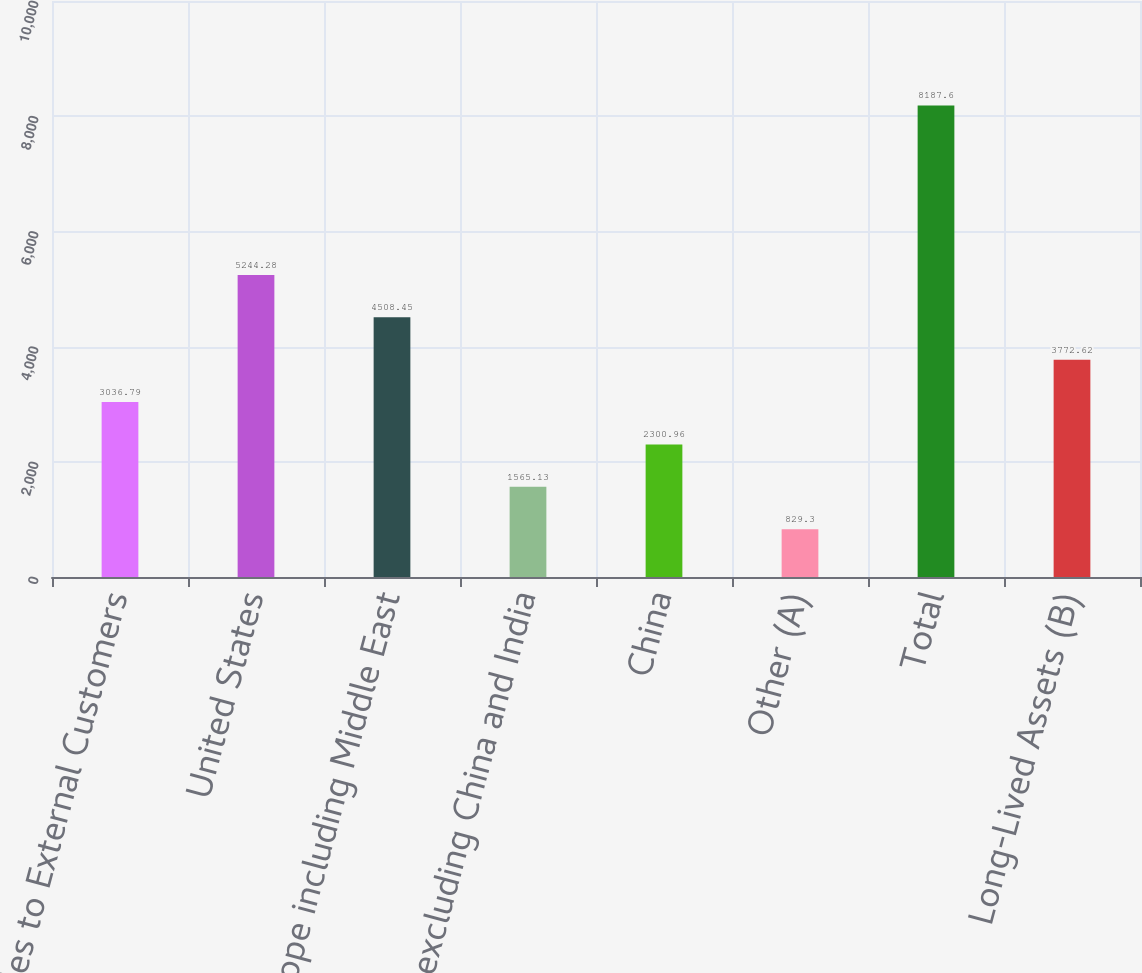Convert chart to OTSL. <chart><loc_0><loc_0><loc_500><loc_500><bar_chart><fcel>Sales to External Customers<fcel>United States<fcel>Europe including Middle East<fcel>Asia excluding China and India<fcel>China<fcel>Other (A)<fcel>Total<fcel>Long-Lived Assets (B)<nl><fcel>3036.79<fcel>5244.28<fcel>4508.45<fcel>1565.13<fcel>2300.96<fcel>829.3<fcel>8187.6<fcel>3772.62<nl></chart> 